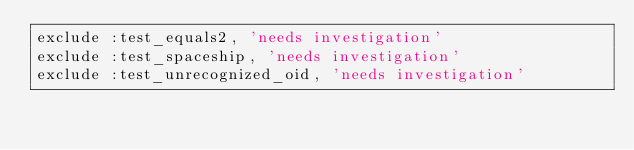<code> <loc_0><loc_0><loc_500><loc_500><_Ruby_>exclude :test_equals2, 'needs investigation'
exclude :test_spaceship, 'needs investigation'
exclude :test_unrecognized_oid, 'needs investigation'
</code> 